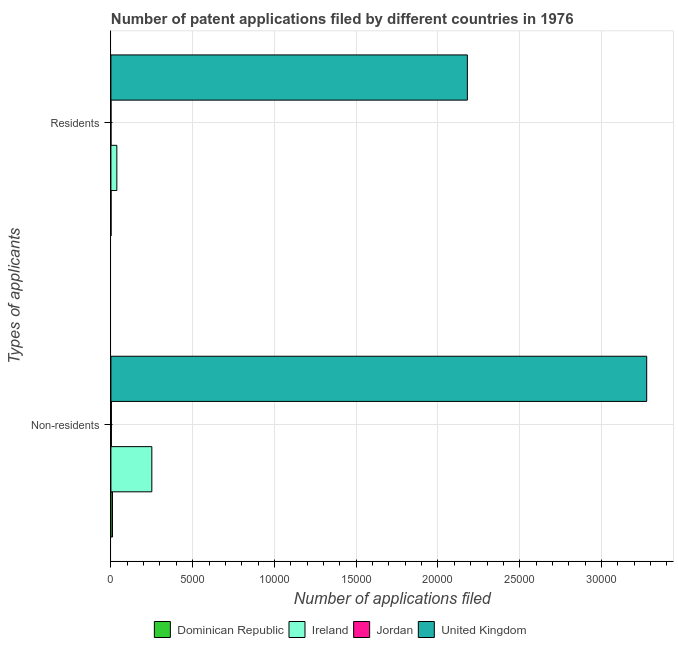How many different coloured bars are there?
Keep it short and to the point. 4. How many groups of bars are there?
Keep it short and to the point. 2. Are the number of bars per tick equal to the number of legend labels?
Your response must be concise. Yes. Are the number of bars on each tick of the Y-axis equal?
Offer a very short reply. Yes. How many bars are there on the 2nd tick from the bottom?
Make the answer very short. 4. What is the label of the 2nd group of bars from the top?
Provide a succinct answer. Non-residents. What is the number of patent applications by residents in United Kingdom?
Ensure brevity in your answer.  2.18e+04. Across all countries, what is the maximum number of patent applications by non residents?
Provide a succinct answer. 3.28e+04. Across all countries, what is the minimum number of patent applications by residents?
Provide a short and direct response. 2. In which country was the number of patent applications by non residents maximum?
Your answer should be very brief. United Kingdom. In which country was the number of patent applications by residents minimum?
Offer a terse response. Jordan. What is the total number of patent applications by non residents in the graph?
Provide a succinct answer. 3.54e+04. What is the difference between the number of patent applications by non residents in Dominican Republic and that in United Kingdom?
Make the answer very short. -3.27e+04. What is the difference between the number of patent applications by residents in Dominican Republic and the number of patent applications by non residents in Ireland?
Keep it short and to the point. -2495. What is the average number of patent applications by residents per country?
Provide a short and direct response. 5542.25. What is the difference between the number of patent applications by residents and number of patent applications by non residents in Dominican Republic?
Your answer should be compact. -89. In how many countries, is the number of patent applications by residents greater than 3000 ?
Give a very brief answer. 1. What is the ratio of the number of patent applications by non residents in Ireland to that in Dominican Republic?
Make the answer very short. 26.06. Is the number of patent applications by residents in Dominican Republic less than that in Ireland?
Your answer should be compact. Yes. In how many countries, is the number of patent applications by residents greater than the average number of patent applications by residents taken over all countries?
Give a very brief answer. 1. What does the 4th bar from the top in Residents represents?
Provide a succinct answer. Dominican Republic. What does the 2nd bar from the bottom in Non-residents represents?
Ensure brevity in your answer.  Ireland. Are all the bars in the graph horizontal?
Your answer should be very brief. Yes. Are the values on the major ticks of X-axis written in scientific E-notation?
Provide a short and direct response. No. Does the graph contain any zero values?
Your answer should be compact. No. Where does the legend appear in the graph?
Give a very brief answer. Bottom center. What is the title of the graph?
Keep it short and to the point. Number of patent applications filed by different countries in 1976. What is the label or title of the X-axis?
Your answer should be compact. Number of applications filed. What is the label or title of the Y-axis?
Your answer should be very brief. Types of applicants. What is the Number of applications filed of Dominican Republic in Non-residents?
Keep it short and to the point. 96. What is the Number of applications filed in Ireland in Non-residents?
Ensure brevity in your answer.  2502. What is the Number of applications filed in Jordan in Non-residents?
Your answer should be very brief. 28. What is the Number of applications filed of United Kingdom in Non-residents?
Provide a short and direct response. 3.28e+04. What is the Number of applications filed in Dominican Republic in Residents?
Your answer should be very brief. 7. What is the Number of applications filed in Ireland in Residents?
Offer a terse response. 363. What is the Number of applications filed in Jordan in Residents?
Offer a terse response. 2. What is the Number of applications filed of United Kingdom in Residents?
Offer a terse response. 2.18e+04. Across all Types of applicants, what is the maximum Number of applications filed of Dominican Republic?
Your answer should be compact. 96. Across all Types of applicants, what is the maximum Number of applications filed in Ireland?
Offer a terse response. 2502. Across all Types of applicants, what is the maximum Number of applications filed of Jordan?
Provide a short and direct response. 28. Across all Types of applicants, what is the maximum Number of applications filed of United Kingdom?
Keep it short and to the point. 3.28e+04. Across all Types of applicants, what is the minimum Number of applications filed in Dominican Republic?
Provide a short and direct response. 7. Across all Types of applicants, what is the minimum Number of applications filed in Ireland?
Make the answer very short. 363. Across all Types of applicants, what is the minimum Number of applications filed of Jordan?
Provide a succinct answer. 2. Across all Types of applicants, what is the minimum Number of applications filed in United Kingdom?
Give a very brief answer. 2.18e+04. What is the total Number of applications filed of Dominican Republic in the graph?
Your response must be concise. 103. What is the total Number of applications filed in Ireland in the graph?
Provide a succinct answer. 2865. What is the total Number of applications filed in Jordan in the graph?
Provide a succinct answer. 30. What is the total Number of applications filed in United Kingdom in the graph?
Your response must be concise. 5.46e+04. What is the difference between the Number of applications filed of Dominican Republic in Non-residents and that in Residents?
Keep it short and to the point. 89. What is the difference between the Number of applications filed in Ireland in Non-residents and that in Residents?
Ensure brevity in your answer.  2139. What is the difference between the Number of applications filed in United Kingdom in Non-residents and that in Residents?
Provide a succinct answer. 1.10e+04. What is the difference between the Number of applications filed in Dominican Republic in Non-residents and the Number of applications filed in Ireland in Residents?
Offer a very short reply. -267. What is the difference between the Number of applications filed of Dominican Republic in Non-residents and the Number of applications filed of Jordan in Residents?
Your response must be concise. 94. What is the difference between the Number of applications filed of Dominican Republic in Non-residents and the Number of applications filed of United Kingdom in Residents?
Keep it short and to the point. -2.17e+04. What is the difference between the Number of applications filed of Ireland in Non-residents and the Number of applications filed of Jordan in Residents?
Your response must be concise. 2500. What is the difference between the Number of applications filed in Ireland in Non-residents and the Number of applications filed in United Kingdom in Residents?
Your answer should be compact. -1.93e+04. What is the difference between the Number of applications filed of Jordan in Non-residents and the Number of applications filed of United Kingdom in Residents?
Your answer should be very brief. -2.18e+04. What is the average Number of applications filed in Dominican Republic per Types of applicants?
Offer a very short reply. 51.5. What is the average Number of applications filed in Ireland per Types of applicants?
Keep it short and to the point. 1432.5. What is the average Number of applications filed of United Kingdom per Types of applicants?
Make the answer very short. 2.73e+04. What is the difference between the Number of applications filed in Dominican Republic and Number of applications filed in Ireland in Non-residents?
Keep it short and to the point. -2406. What is the difference between the Number of applications filed of Dominican Republic and Number of applications filed of Jordan in Non-residents?
Provide a succinct answer. 68. What is the difference between the Number of applications filed in Dominican Republic and Number of applications filed in United Kingdom in Non-residents?
Offer a terse response. -3.27e+04. What is the difference between the Number of applications filed of Ireland and Number of applications filed of Jordan in Non-residents?
Offer a very short reply. 2474. What is the difference between the Number of applications filed in Ireland and Number of applications filed in United Kingdom in Non-residents?
Your response must be concise. -3.03e+04. What is the difference between the Number of applications filed of Jordan and Number of applications filed of United Kingdom in Non-residents?
Ensure brevity in your answer.  -3.27e+04. What is the difference between the Number of applications filed in Dominican Republic and Number of applications filed in Ireland in Residents?
Your response must be concise. -356. What is the difference between the Number of applications filed in Dominican Republic and Number of applications filed in United Kingdom in Residents?
Offer a very short reply. -2.18e+04. What is the difference between the Number of applications filed in Ireland and Number of applications filed in Jordan in Residents?
Offer a terse response. 361. What is the difference between the Number of applications filed of Ireland and Number of applications filed of United Kingdom in Residents?
Offer a very short reply. -2.14e+04. What is the difference between the Number of applications filed in Jordan and Number of applications filed in United Kingdom in Residents?
Provide a succinct answer. -2.18e+04. What is the ratio of the Number of applications filed of Dominican Republic in Non-residents to that in Residents?
Offer a terse response. 13.71. What is the ratio of the Number of applications filed of Ireland in Non-residents to that in Residents?
Offer a terse response. 6.89. What is the ratio of the Number of applications filed of United Kingdom in Non-residents to that in Residents?
Keep it short and to the point. 1.5. What is the difference between the highest and the second highest Number of applications filed of Dominican Republic?
Offer a very short reply. 89. What is the difference between the highest and the second highest Number of applications filed in Ireland?
Give a very brief answer. 2139. What is the difference between the highest and the second highest Number of applications filed of United Kingdom?
Make the answer very short. 1.10e+04. What is the difference between the highest and the lowest Number of applications filed in Dominican Republic?
Make the answer very short. 89. What is the difference between the highest and the lowest Number of applications filed of Ireland?
Offer a terse response. 2139. What is the difference between the highest and the lowest Number of applications filed in Jordan?
Offer a terse response. 26. What is the difference between the highest and the lowest Number of applications filed of United Kingdom?
Give a very brief answer. 1.10e+04. 